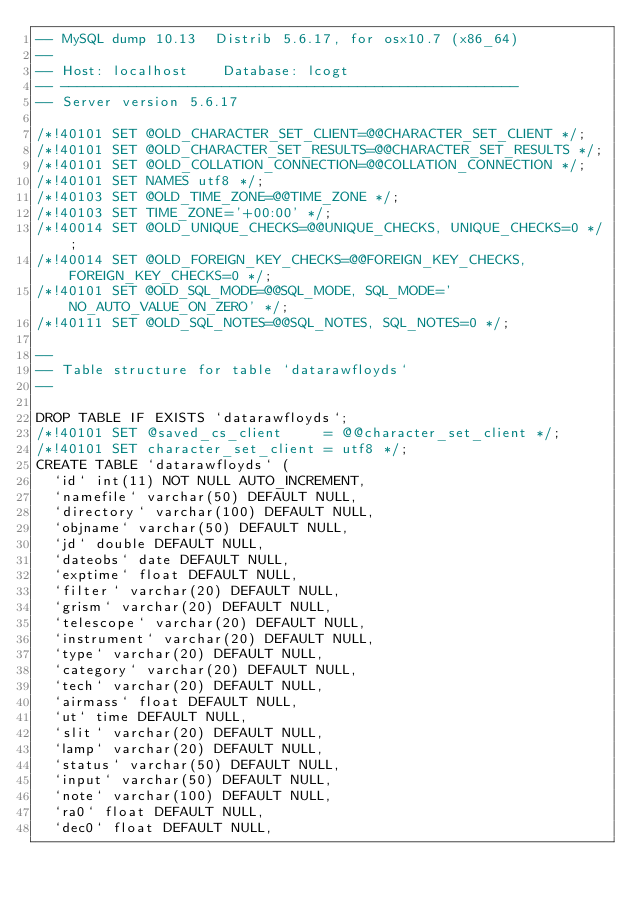<code> <loc_0><loc_0><loc_500><loc_500><_SQL_>-- MySQL dump 10.13  Distrib 5.6.17, for osx10.7 (x86_64)
--
-- Host: localhost    Database: lcogt
-- ------------------------------------------------------
-- Server version	5.6.17

/*!40101 SET @OLD_CHARACTER_SET_CLIENT=@@CHARACTER_SET_CLIENT */;
/*!40101 SET @OLD_CHARACTER_SET_RESULTS=@@CHARACTER_SET_RESULTS */;
/*!40101 SET @OLD_COLLATION_CONNECTION=@@COLLATION_CONNECTION */;
/*!40101 SET NAMES utf8 */;
/*!40103 SET @OLD_TIME_ZONE=@@TIME_ZONE */;
/*!40103 SET TIME_ZONE='+00:00' */;
/*!40014 SET @OLD_UNIQUE_CHECKS=@@UNIQUE_CHECKS, UNIQUE_CHECKS=0 */;
/*!40014 SET @OLD_FOREIGN_KEY_CHECKS=@@FOREIGN_KEY_CHECKS, FOREIGN_KEY_CHECKS=0 */;
/*!40101 SET @OLD_SQL_MODE=@@SQL_MODE, SQL_MODE='NO_AUTO_VALUE_ON_ZERO' */;
/*!40111 SET @OLD_SQL_NOTES=@@SQL_NOTES, SQL_NOTES=0 */;

--
-- Table structure for table `datarawfloyds`
--

DROP TABLE IF EXISTS `datarawfloyds`;
/*!40101 SET @saved_cs_client     = @@character_set_client */;
/*!40101 SET character_set_client = utf8 */;
CREATE TABLE `datarawfloyds` (
  `id` int(11) NOT NULL AUTO_INCREMENT,
  `namefile` varchar(50) DEFAULT NULL,
  `directory` varchar(100) DEFAULT NULL,
  `objname` varchar(50) DEFAULT NULL,
  `jd` double DEFAULT NULL,
  `dateobs` date DEFAULT NULL,
  `exptime` float DEFAULT NULL,
  `filter` varchar(20) DEFAULT NULL,
  `grism` varchar(20) DEFAULT NULL,
  `telescope` varchar(20) DEFAULT NULL,
  `instrument` varchar(20) DEFAULT NULL,
  `type` varchar(20) DEFAULT NULL,
  `category` varchar(20) DEFAULT NULL,
  `tech` varchar(20) DEFAULT NULL,
  `airmass` float DEFAULT NULL,
  `ut` time DEFAULT NULL,
  `slit` varchar(20) DEFAULT NULL,
  `lamp` varchar(20) DEFAULT NULL,
  `status` varchar(50) DEFAULT NULL,
  `input` varchar(50) DEFAULT NULL,
  `note` varchar(100) DEFAULT NULL,
  `ra0` float DEFAULT NULL,
  `dec0` float DEFAULT NULL,</code> 